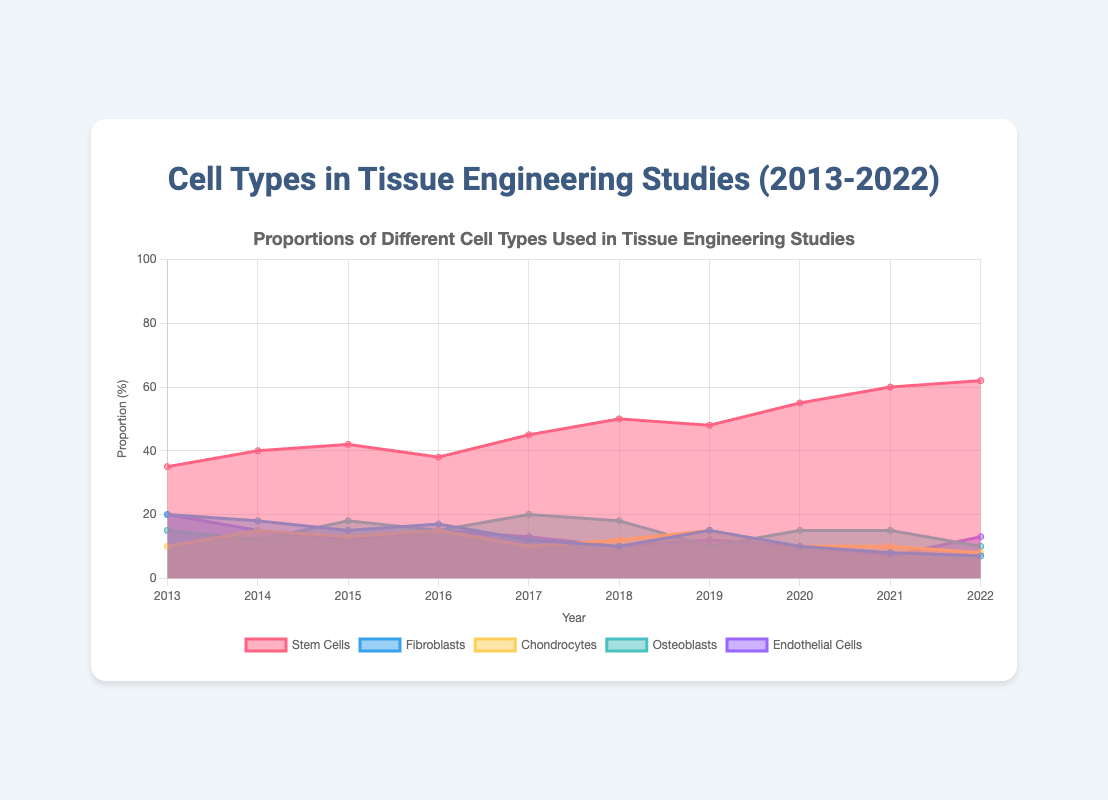What is the title of the chart? The title is written at the top center of the chart.
Answer: Proportions of Different Cell Types Used in Tissue Engineering Studies What are the labels for the x-axis and y-axis? These labels are located at the bottom and side of the chart respectively.
Answer: Year, Proportion (%) Which cell type had the highest proportion in the year 2022? The figure shows a unique maximum height for Stem Cells in 2022.
Answer: Stem Cells How did the proportion of Fibroblasts change from 2013 to 2022? Inspect the slope or drop of the line representing Fibroblasts over the years.
Answer: Decreased Which cell type has the most significant variation in proportions over the decade? Analyze the area variation (increases and decreases) of all cell types.
Answer: Stem Cells What is the combined proportion of Osteoblasts and Endothelial Cells in 2017? Add the proportions of Osteoblasts and Endothelial Cells for 2017.
Answer: 33% In which year did Chondrocytes reach their highest proportion, and what was the value? Look for the peak value in the Chondrocytes line.
Answer: 2014, 15% How does the proportion of Stem Cells in 2018 compare to that in 2020? Compare the heights of Stem Cells in 2018 and 2020.
Answer: 50% in 2018, 55% in 2020 Which years saw the largest continuous increase in the proportion of Stem Cells? Identify the segments of the Stem Cell line where the slope is steepest upwards.
Answer: 2014 to 2015 and 2020 to 2021 What was the proportion of Endothelial Cells in 2016, and how does it compare to 2022? Compare Endothelial Cells' proportion in 2016 and 2022.
Answer: 15% in 2016, 13% in 2022 